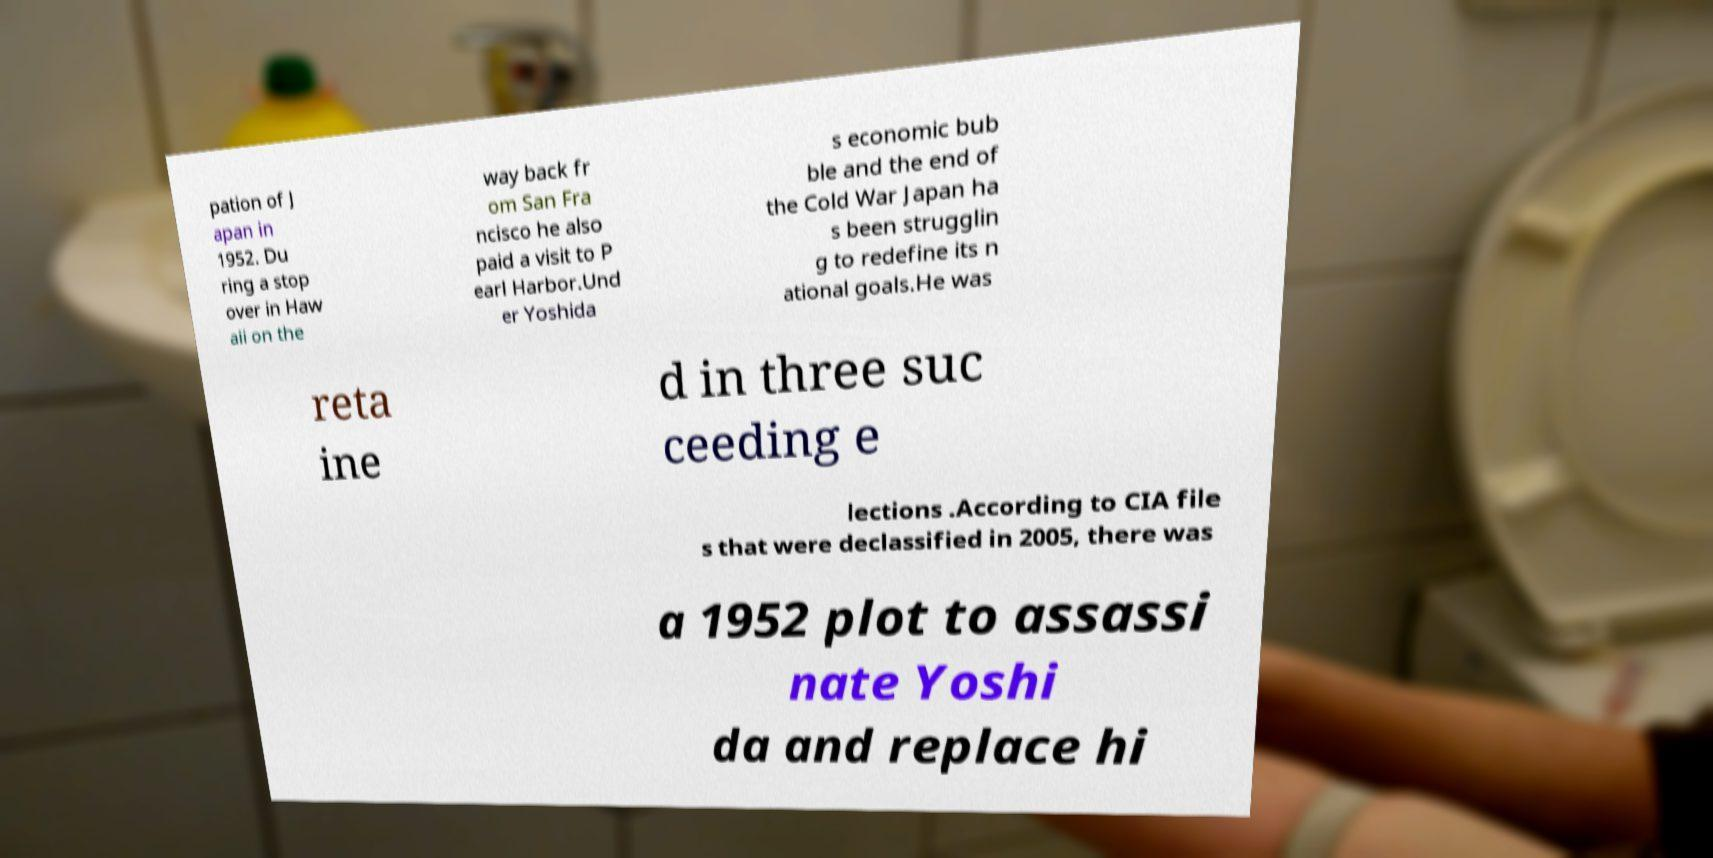Could you extract and type out the text from this image? pation of J apan in 1952. Du ring a stop over in Haw aii on the way back fr om San Fra ncisco he also paid a visit to P earl Harbor.Und er Yoshida s economic bub ble and the end of the Cold War Japan ha s been strugglin g to redefine its n ational goals.He was reta ine d in three suc ceeding e lections .According to CIA file s that were declassified in 2005, there was a 1952 plot to assassi nate Yoshi da and replace hi 